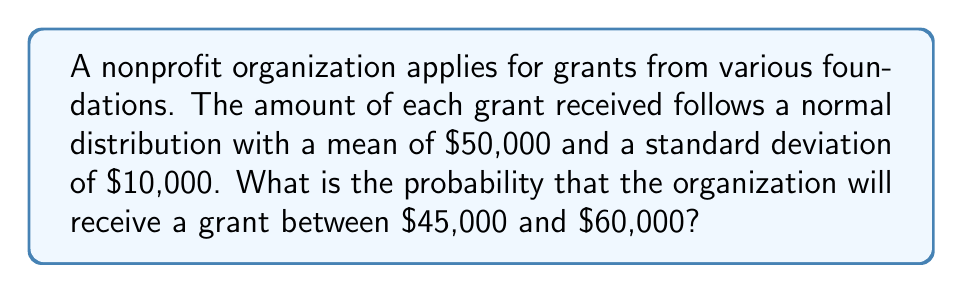Can you solve this math problem? To solve this problem, we'll use the properties of the normal distribution and the z-score formula. Here's a step-by-step approach:

1) First, we need to calculate the z-scores for both $45,000 and $60,000.

   The z-score formula is: $z = \frac{x - \mu}{\sigma}$

   Where:
   $x$ is the value of interest
   $\mu$ is the mean
   $\sigma$ is the standard deviation

2) For $45,000:
   z_1 = \frac{45000 - 50000}{10000} = -0.5$

3) For $60,000:
   z_2 = \frac{60000 - 50000}{10000} = 1$

4) Now, we need to find the area under the standard normal curve between these two z-scores.

5) Using a standard normal distribution table or calculator:
   P(Z < -0.5) ≈ 0.3085
   P(Z < 1) ≈ 0.8413

6) The probability we're looking for is the difference between these two:
   P(-0.5 < Z < 1) = 0.8413 - 0.3085 = 0.5328

Therefore, the probability of receiving a grant between $45,000 and $60,000 is approximately 0.5328 or 53.28%.
Answer: 0.5328 or 53.28% 